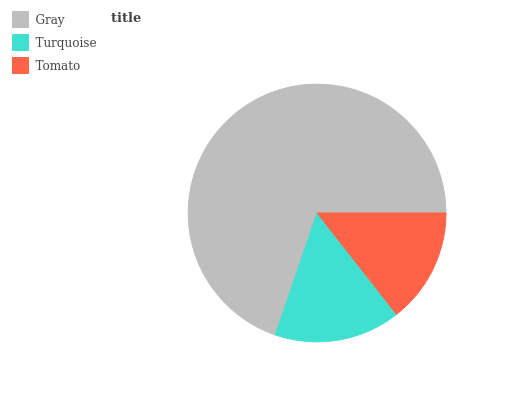Is Tomato the minimum?
Answer yes or no. Yes. Is Gray the maximum?
Answer yes or no. Yes. Is Turquoise the minimum?
Answer yes or no. No. Is Turquoise the maximum?
Answer yes or no. No. Is Gray greater than Turquoise?
Answer yes or no. Yes. Is Turquoise less than Gray?
Answer yes or no. Yes. Is Turquoise greater than Gray?
Answer yes or no. No. Is Gray less than Turquoise?
Answer yes or no. No. Is Turquoise the high median?
Answer yes or no. Yes. Is Turquoise the low median?
Answer yes or no. Yes. Is Tomato the high median?
Answer yes or no. No. Is Tomato the low median?
Answer yes or no. No. 